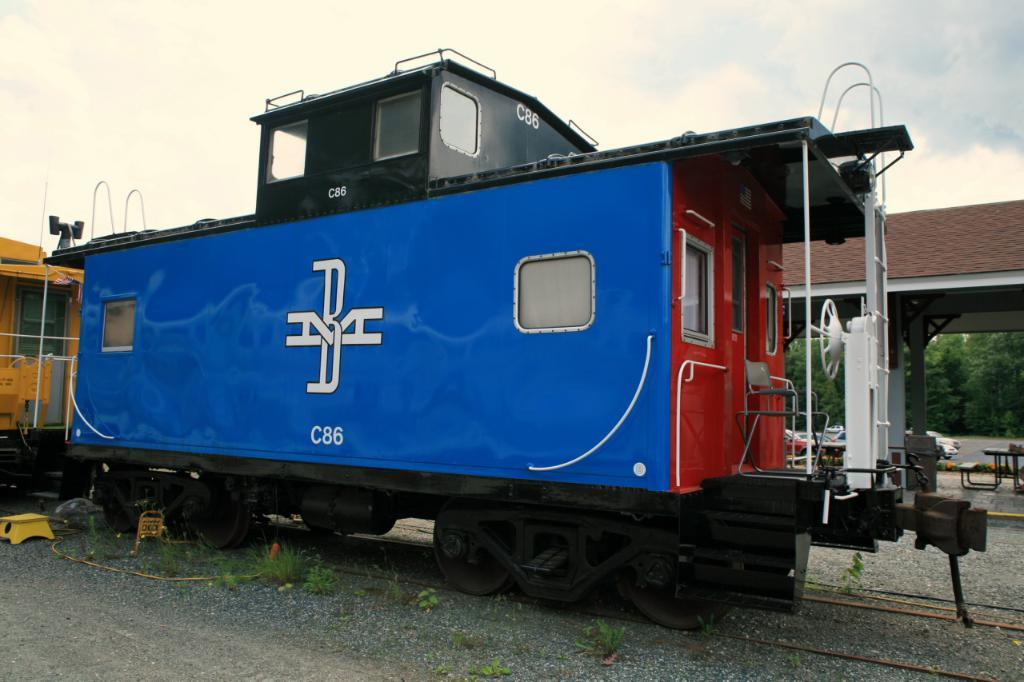What is the main subject of the picture? The main subject of the picture is a train. What can be seen in the background of the image? There are trees in the image. What else is visible in the picture besides the train and trees? The sky is visible in the image. What type of yarn is being used to decorate the train in the image? There is no yarn present in the image, and therefore no such decoration can be observed. 